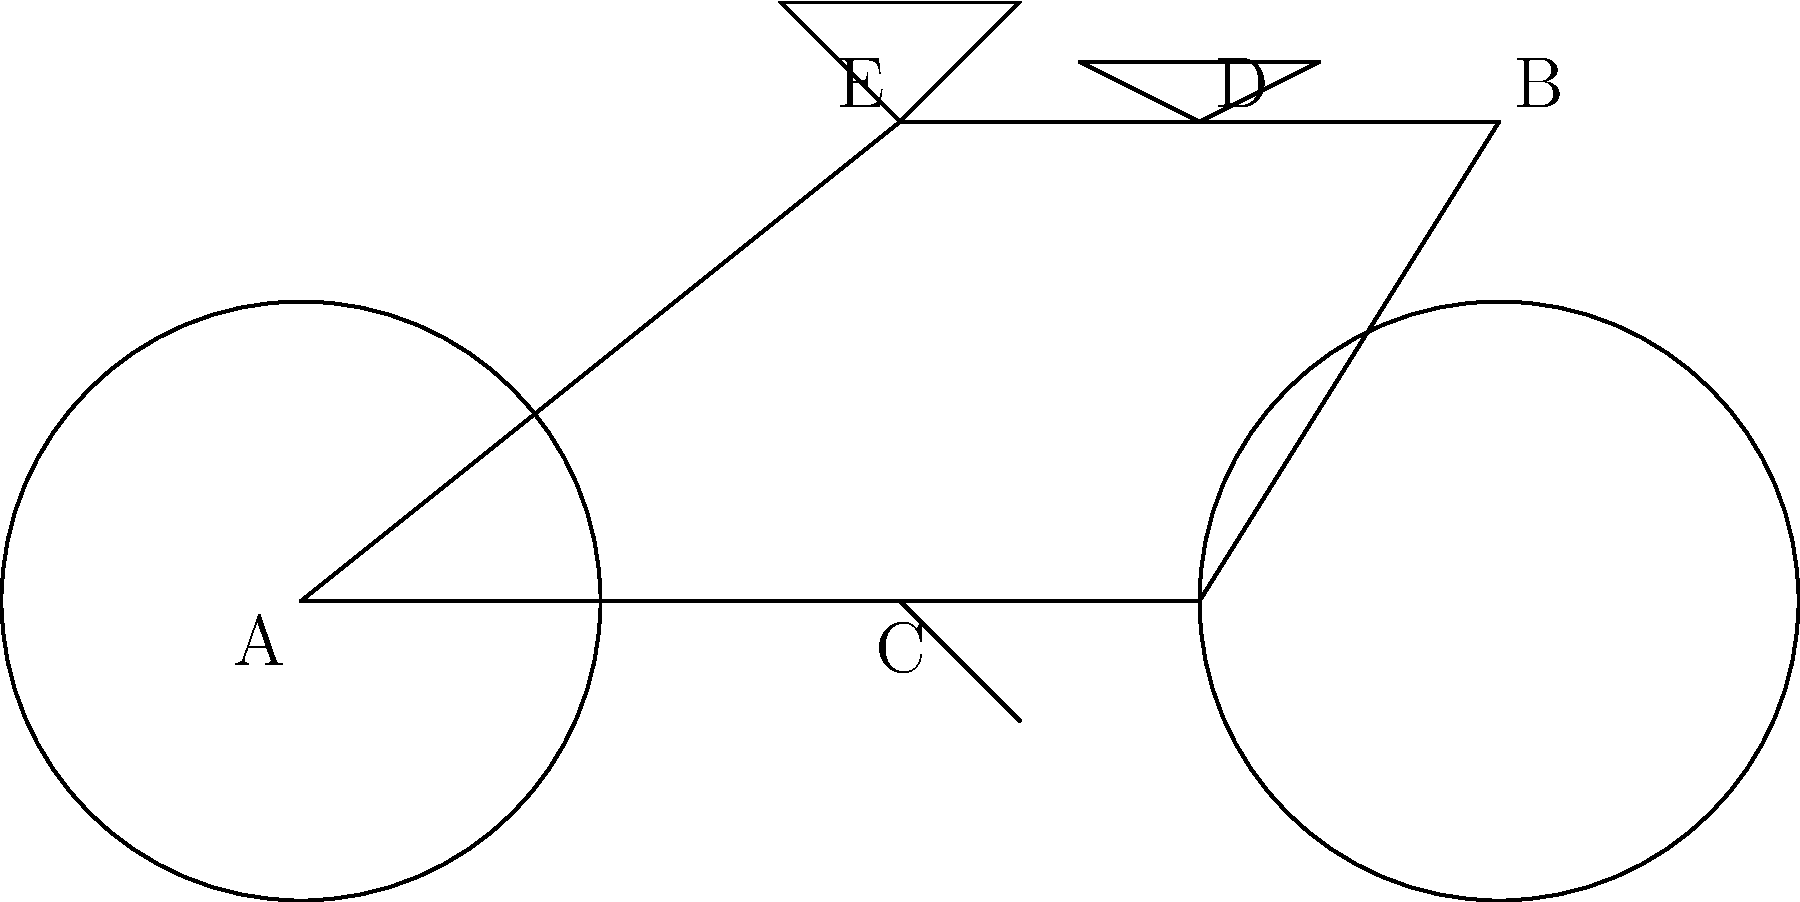Identify the key components of a bicycle labeled A through E in the diagram, and briefly explain their primary functions. To identify the key components of a bicycle and their functions, let's go through each labeled part:

1. A: Wheels
   Function: Provide the point of contact with the ground, allowing the bicycle to roll and move forward.
   
2. B: Handlebars
   Function: Allow the rider to steer the bicycle and maintain balance.
   
3. C: Pedals
   Function: Provide a platform for the rider to apply force, which is converted into rotational motion to propel the bicycle forward.
   
4. D: Seat (or Saddle)
   Function: Supports the rider's weight and provides a comfortable sitting position while cycling.
   
5. E: Frame
   Function: Forms the main structure of the bicycle, connecting all other components and providing stability and support.

Each of these components plays a crucial role in the overall function and performance of the bicycle:

- The wheels (A) are essential for movement and stability.
- The handlebars (B) are critical for control and navigation.
- The pedals (C) are the primary means of propulsion.
- The seat (D) ensures rider comfort and proper positioning.
- The frame (E) ties everything together and determines the bicycle's overall geometry and handling characteristics.

Understanding these components and their functions is crucial for efficient and safe cycling, especially for someone who uses bike lanes as their primary mode of transportation.
Answer: A: Wheels (rolling), B: Handlebars (steering), C: Pedals (propulsion), D: Seat (support), E: Frame (structure) 